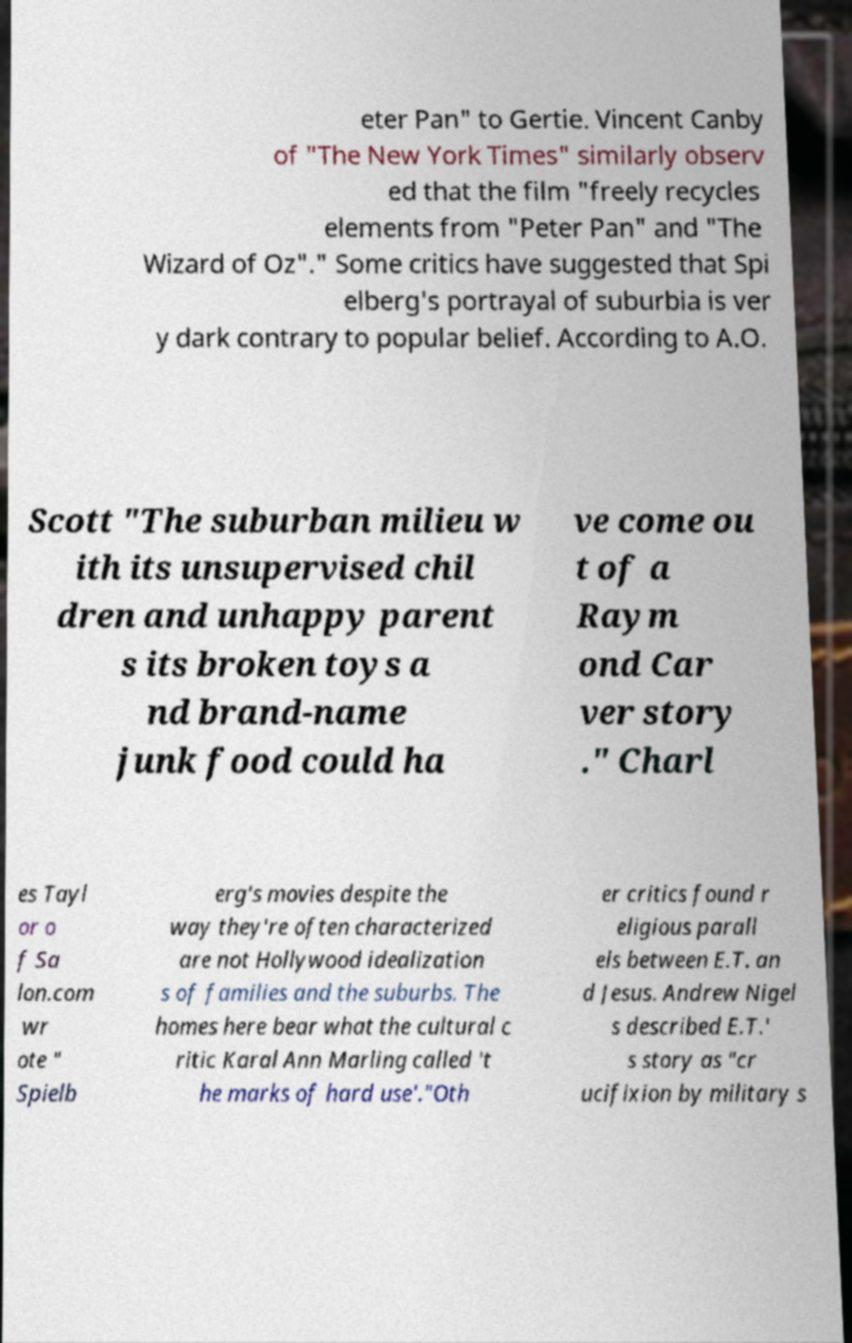Can you read and provide the text displayed in the image?This photo seems to have some interesting text. Can you extract and type it out for me? eter Pan" to Gertie. Vincent Canby of "The New York Times" similarly observ ed that the film "freely recycles elements from "Peter Pan" and "The Wizard of Oz"." Some critics have suggested that Spi elberg's portrayal of suburbia is ver y dark contrary to popular belief. According to A.O. Scott "The suburban milieu w ith its unsupervised chil dren and unhappy parent s its broken toys a nd brand-name junk food could ha ve come ou t of a Raym ond Car ver story ." Charl es Tayl or o f Sa lon.com wr ote " Spielb erg's movies despite the way they're often characterized are not Hollywood idealization s of families and the suburbs. The homes here bear what the cultural c ritic Karal Ann Marling called 't he marks of hard use'."Oth er critics found r eligious parall els between E.T. an d Jesus. Andrew Nigel s described E.T.' s story as "cr ucifixion by military s 